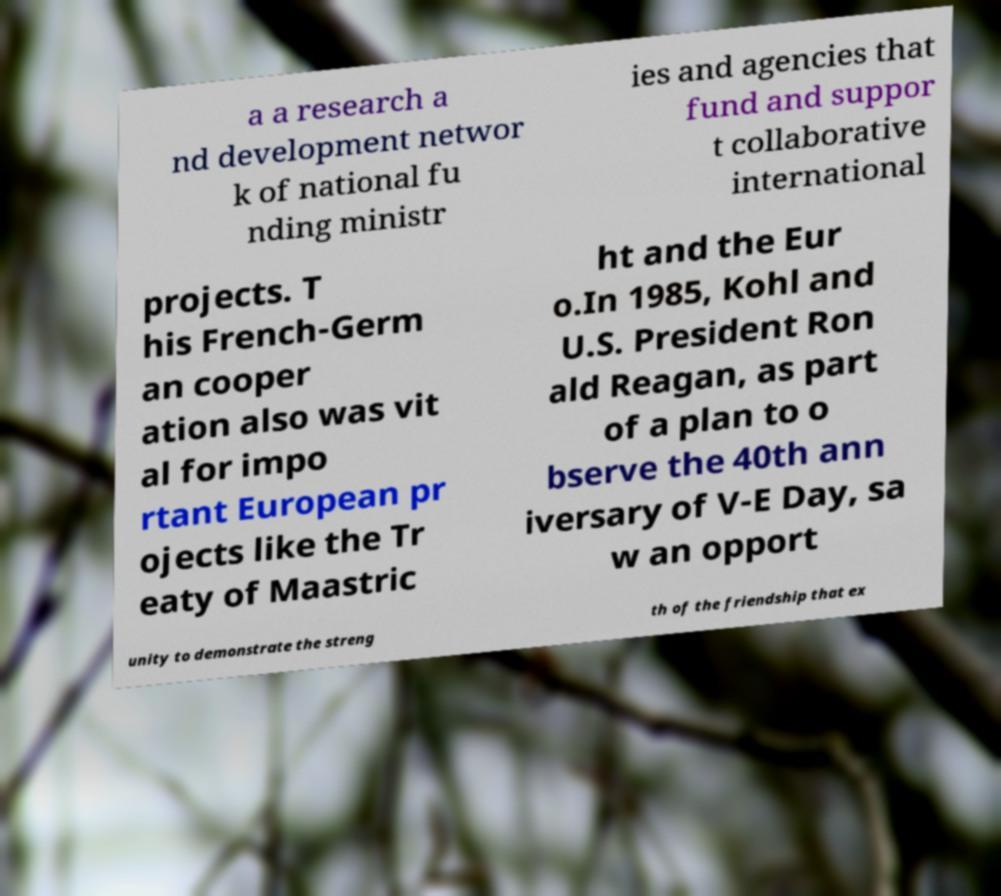For documentation purposes, I need the text within this image transcribed. Could you provide that? a a research a nd development networ k of national fu nding ministr ies and agencies that fund and suppor t collaborative international projects. T his French-Germ an cooper ation also was vit al for impo rtant European pr ojects like the Tr eaty of Maastric ht and the Eur o.In 1985, Kohl and U.S. President Ron ald Reagan, as part of a plan to o bserve the 40th ann iversary of V-E Day, sa w an opport unity to demonstrate the streng th of the friendship that ex 